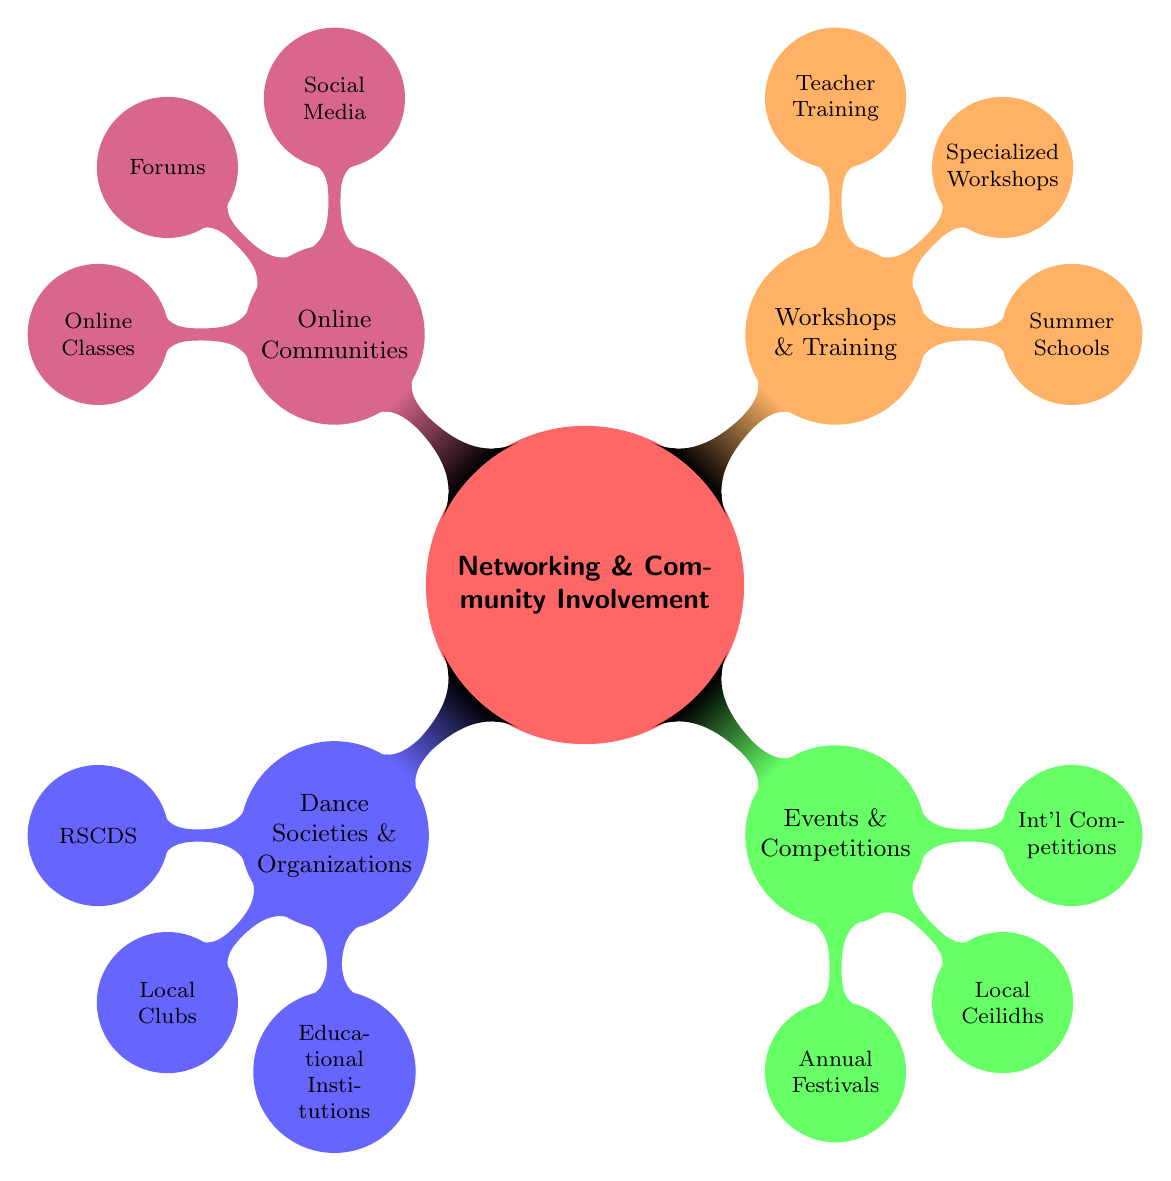What are the main categories in the mind map? The mind map has four primary categories branching out from the central node "Networking & Community Involvement": Dance Societies & Organizations, Events & Competitions, Workshops & Training, and Online Communities.
Answer: Four How many nodes are under "Dance Societies & Organizations"? This category includes three nodes: RSCDS, Local Clubs, and Educational Institutions. Therefore, the count of nodes is three.
Answer: Three Which category contains "Summer Schools"? "Summer Schools" is located under the "Workshops & Training" category as one of its nodes.
Answer: Workshops & Training What type of events does the mind map categorize under "Events & Competitions"? The mind map categorizes three types of events under this section: Annual Festivals, Local Ceilidhs, and International Competitions.
Answer: Three Which node is associated with both local and international formats? The "Local Ceilidhs" node is associated with local formats, while "International Competitions" refers to global formats; hence both local and international opportunities are highlighted in the Events & Competitions category.
Answer: Local Ceilidhs, International Competitions How are online communities represented in this mind map? Online communities are represented as a separate category consisting of three nodes: Social Media, Forums, and Online Classes.
Answer: Social Media, Forums, Online Classes Which two categories involve active engagement in the community? "Events & Competitions" and "Workshops & Training" both involve active engagement, encouraging participants to attend, learn, and connect with others.
Answer: Events & Competitions, Workshops & Training What is the primary focus of the "Royal Scottish Country Dance Society (RSCDS)" node? The RSCDS node signifies an organization dedicated to promoting Scottish Country Dance, thus emphasizing the cultural and educational aspects of the dance community.
Answer: Promote Scottish Country Dance How many nodes under "Online Communities" are focused on interaction among members? The nodes "Social Media" and "Forums" primarily focus on interaction and community engagement among dancers and enthusiasts. Therefore, there are two nodes that represent this aspect.
Answer: Two 